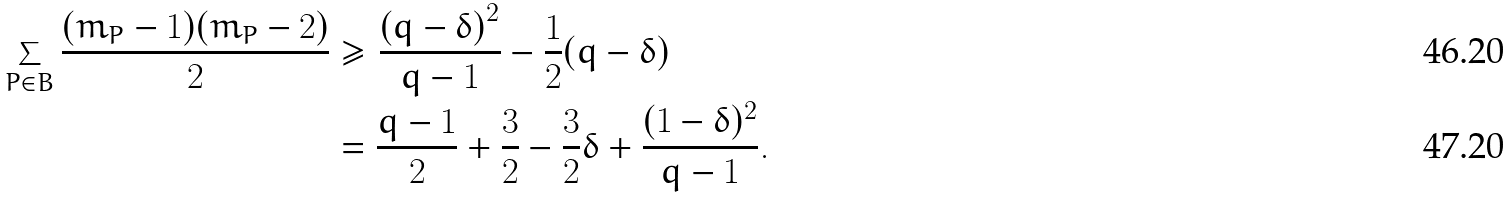<formula> <loc_0><loc_0><loc_500><loc_500>\sum _ { P \in B } \frac { ( m _ { P } - 1 ) ( m _ { P } - 2 ) } { 2 } & \geq \frac { \left ( q - \delta \right ) ^ { 2 } } { q - 1 } - \frac { 1 } { 2 } ( q - \delta ) \\ & = \frac { q - 1 } { 2 } + \frac { 3 } { 2 } - \frac { 3 } { 2 } \delta + \frac { ( 1 - \delta ) ^ { 2 } } { q - 1 } .</formula> 